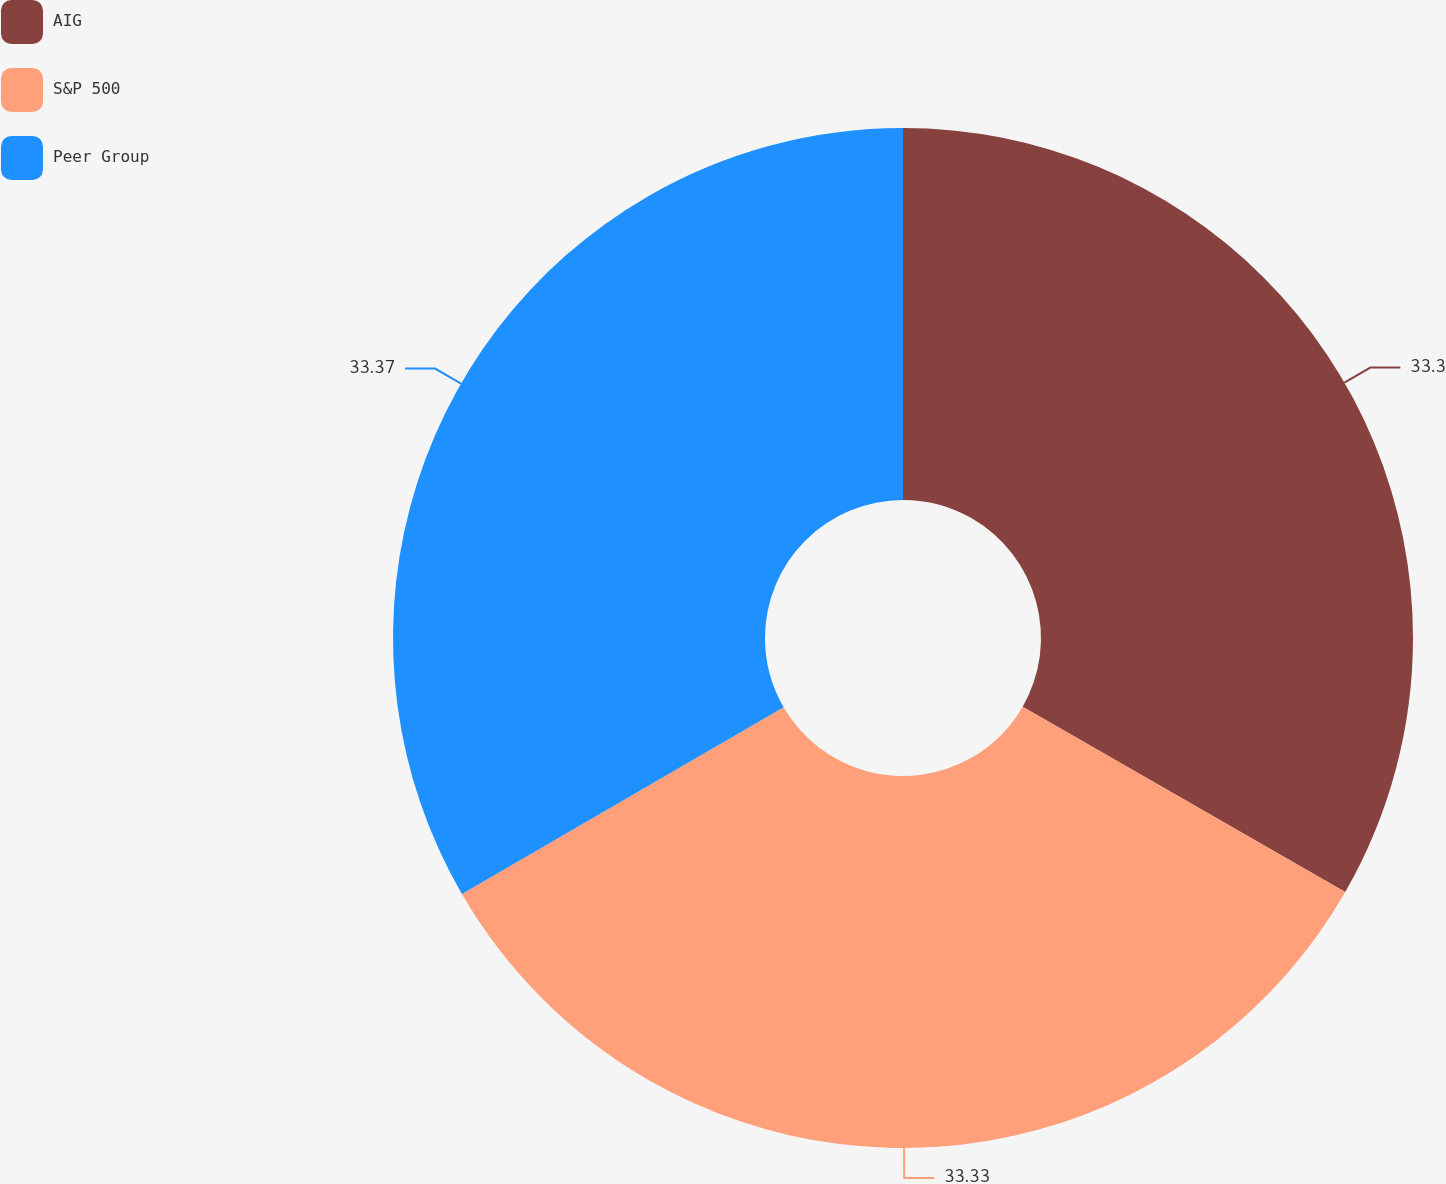<chart> <loc_0><loc_0><loc_500><loc_500><pie_chart><fcel>AIG<fcel>S&P 500<fcel>Peer Group<nl><fcel>33.3%<fcel>33.33%<fcel>33.37%<nl></chart> 